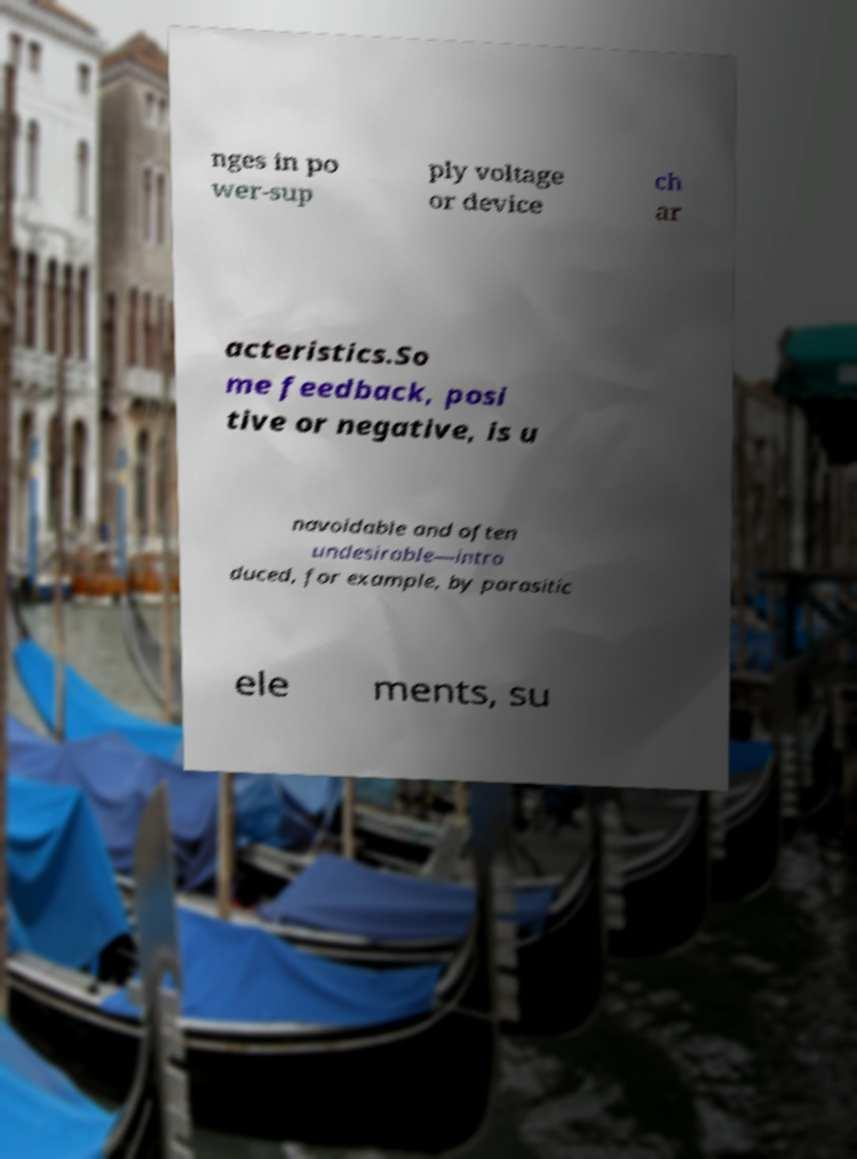Could you extract and type out the text from this image? nges in po wer-sup ply voltage or device ch ar acteristics.So me feedback, posi tive or negative, is u navoidable and often undesirable—intro duced, for example, by parasitic ele ments, su 